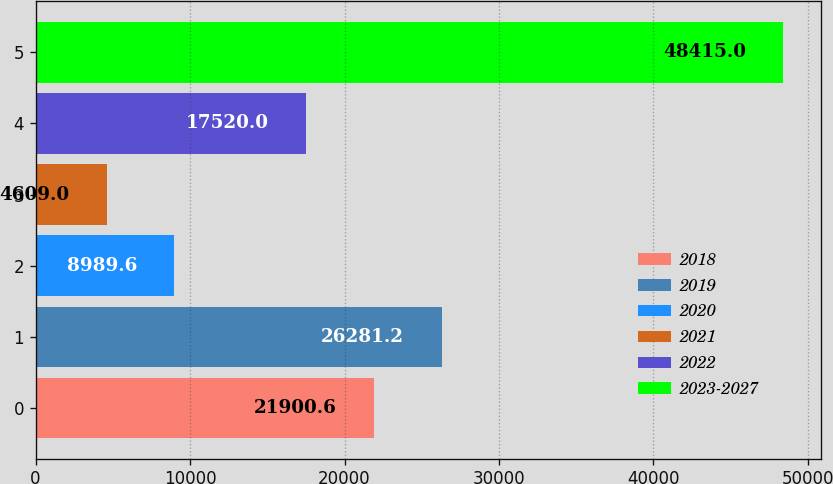Convert chart to OTSL. <chart><loc_0><loc_0><loc_500><loc_500><bar_chart><fcel>2018<fcel>2019<fcel>2020<fcel>2021<fcel>2022<fcel>2023-2027<nl><fcel>21900.6<fcel>26281.2<fcel>8989.6<fcel>4609<fcel>17520<fcel>48415<nl></chart> 